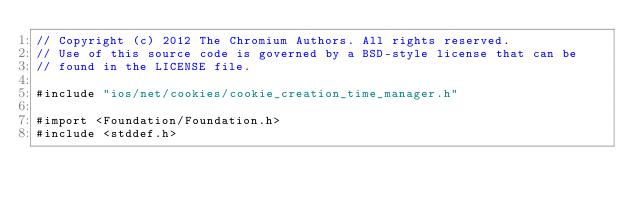Convert code to text. <code><loc_0><loc_0><loc_500><loc_500><_ObjectiveC_>// Copyright (c) 2012 The Chromium Authors. All rights reserved.
// Use of this source code is governed by a BSD-style license that can be
// found in the LICENSE file.

#include "ios/net/cookies/cookie_creation_time_manager.h"

#import <Foundation/Foundation.h>
#include <stddef.h>
</code> 